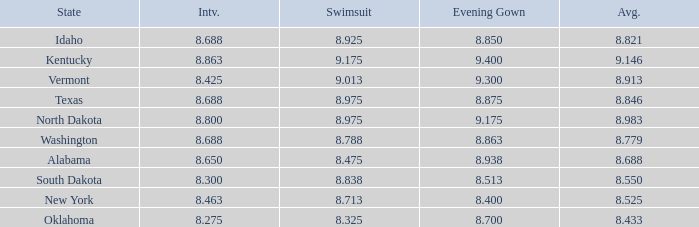What is the lowest average of the contestant with an interview of 8.275 and an evening gown bigger than 8.7? None. 